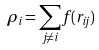Convert formula to latex. <formula><loc_0><loc_0><loc_500><loc_500>\rho _ { i } = \sum _ { j \neq i } f ( r _ { i j } )</formula> 